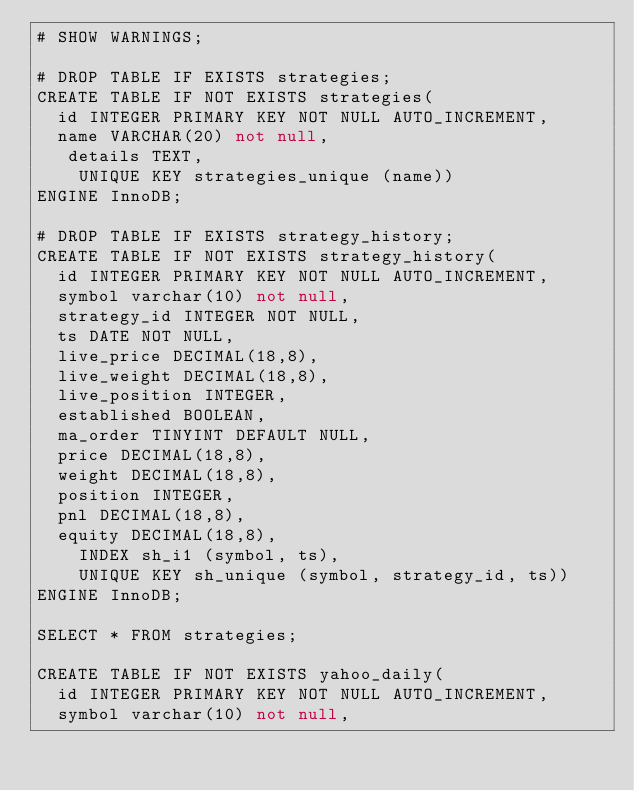Convert code to text. <code><loc_0><loc_0><loc_500><loc_500><_SQL_># SHOW WARNINGS;

# DROP TABLE IF EXISTS strategies;
CREATE TABLE IF NOT EXISTS strategies(
	id INTEGER PRIMARY KEY NOT NULL AUTO_INCREMENT,
	name VARCHAR(20) not null,
   details TEXT,
    UNIQUE KEY strategies_unique (name))
ENGINE InnoDB;

# DROP TABLE IF EXISTS strategy_history;
CREATE TABLE IF NOT EXISTS strategy_history(
	id INTEGER PRIMARY KEY NOT NULL AUTO_INCREMENT,
	symbol varchar(10) not null,
	strategy_id INTEGER NOT NULL,
	ts DATE NOT NULL,
	live_price DECIMAL(18,8),
	live_weight DECIMAL(18,8),
	live_position INTEGER,
	established BOOLEAN,
	ma_order TINYINT DEFAULT NULL,
	price DECIMAL(18,8),
	weight DECIMAL(18,8),
	position INTEGER,
	pnl DECIMAL(18,8),
	equity DECIMAL(18,8),
    INDEX sh_i1 (symbol, ts),
    UNIQUE KEY sh_unique (symbol, strategy_id, ts))
ENGINE InnoDB;

SELECT * FROM strategies;

CREATE TABLE IF NOT EXISTS yahoo_daily(
	id INTEGER PRIMARY KEY NOT NULL AUTO_INCREMENT,
	symbol varchar(10) not null,</code> 